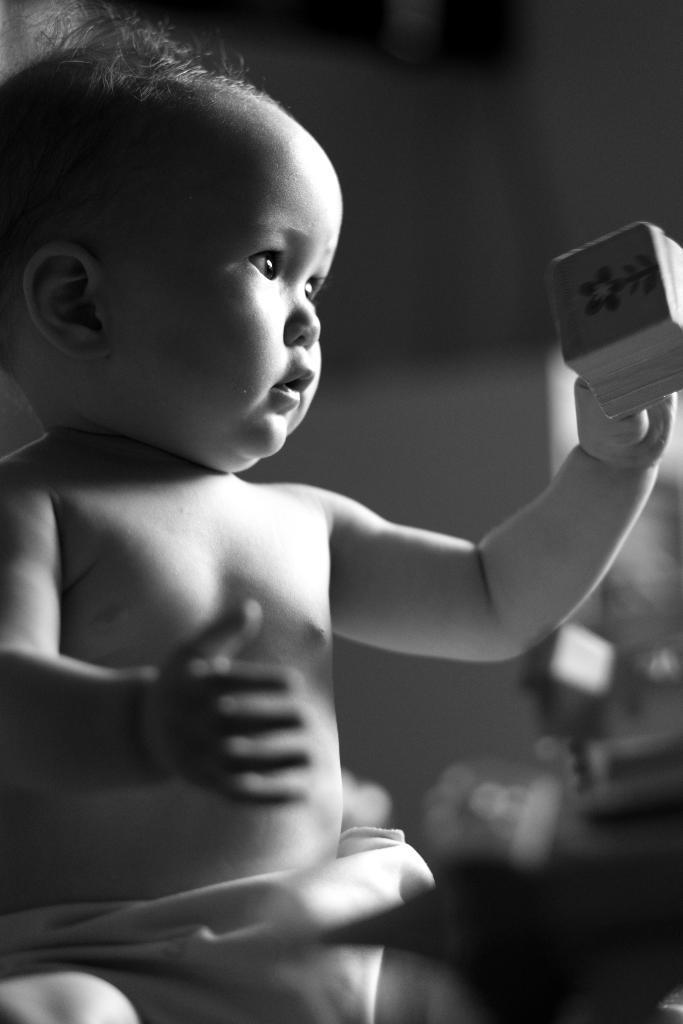Can you describe this image briefly? This is a black and white image. In this image we can see a baby holding something in the hand. In the background it is blur. 